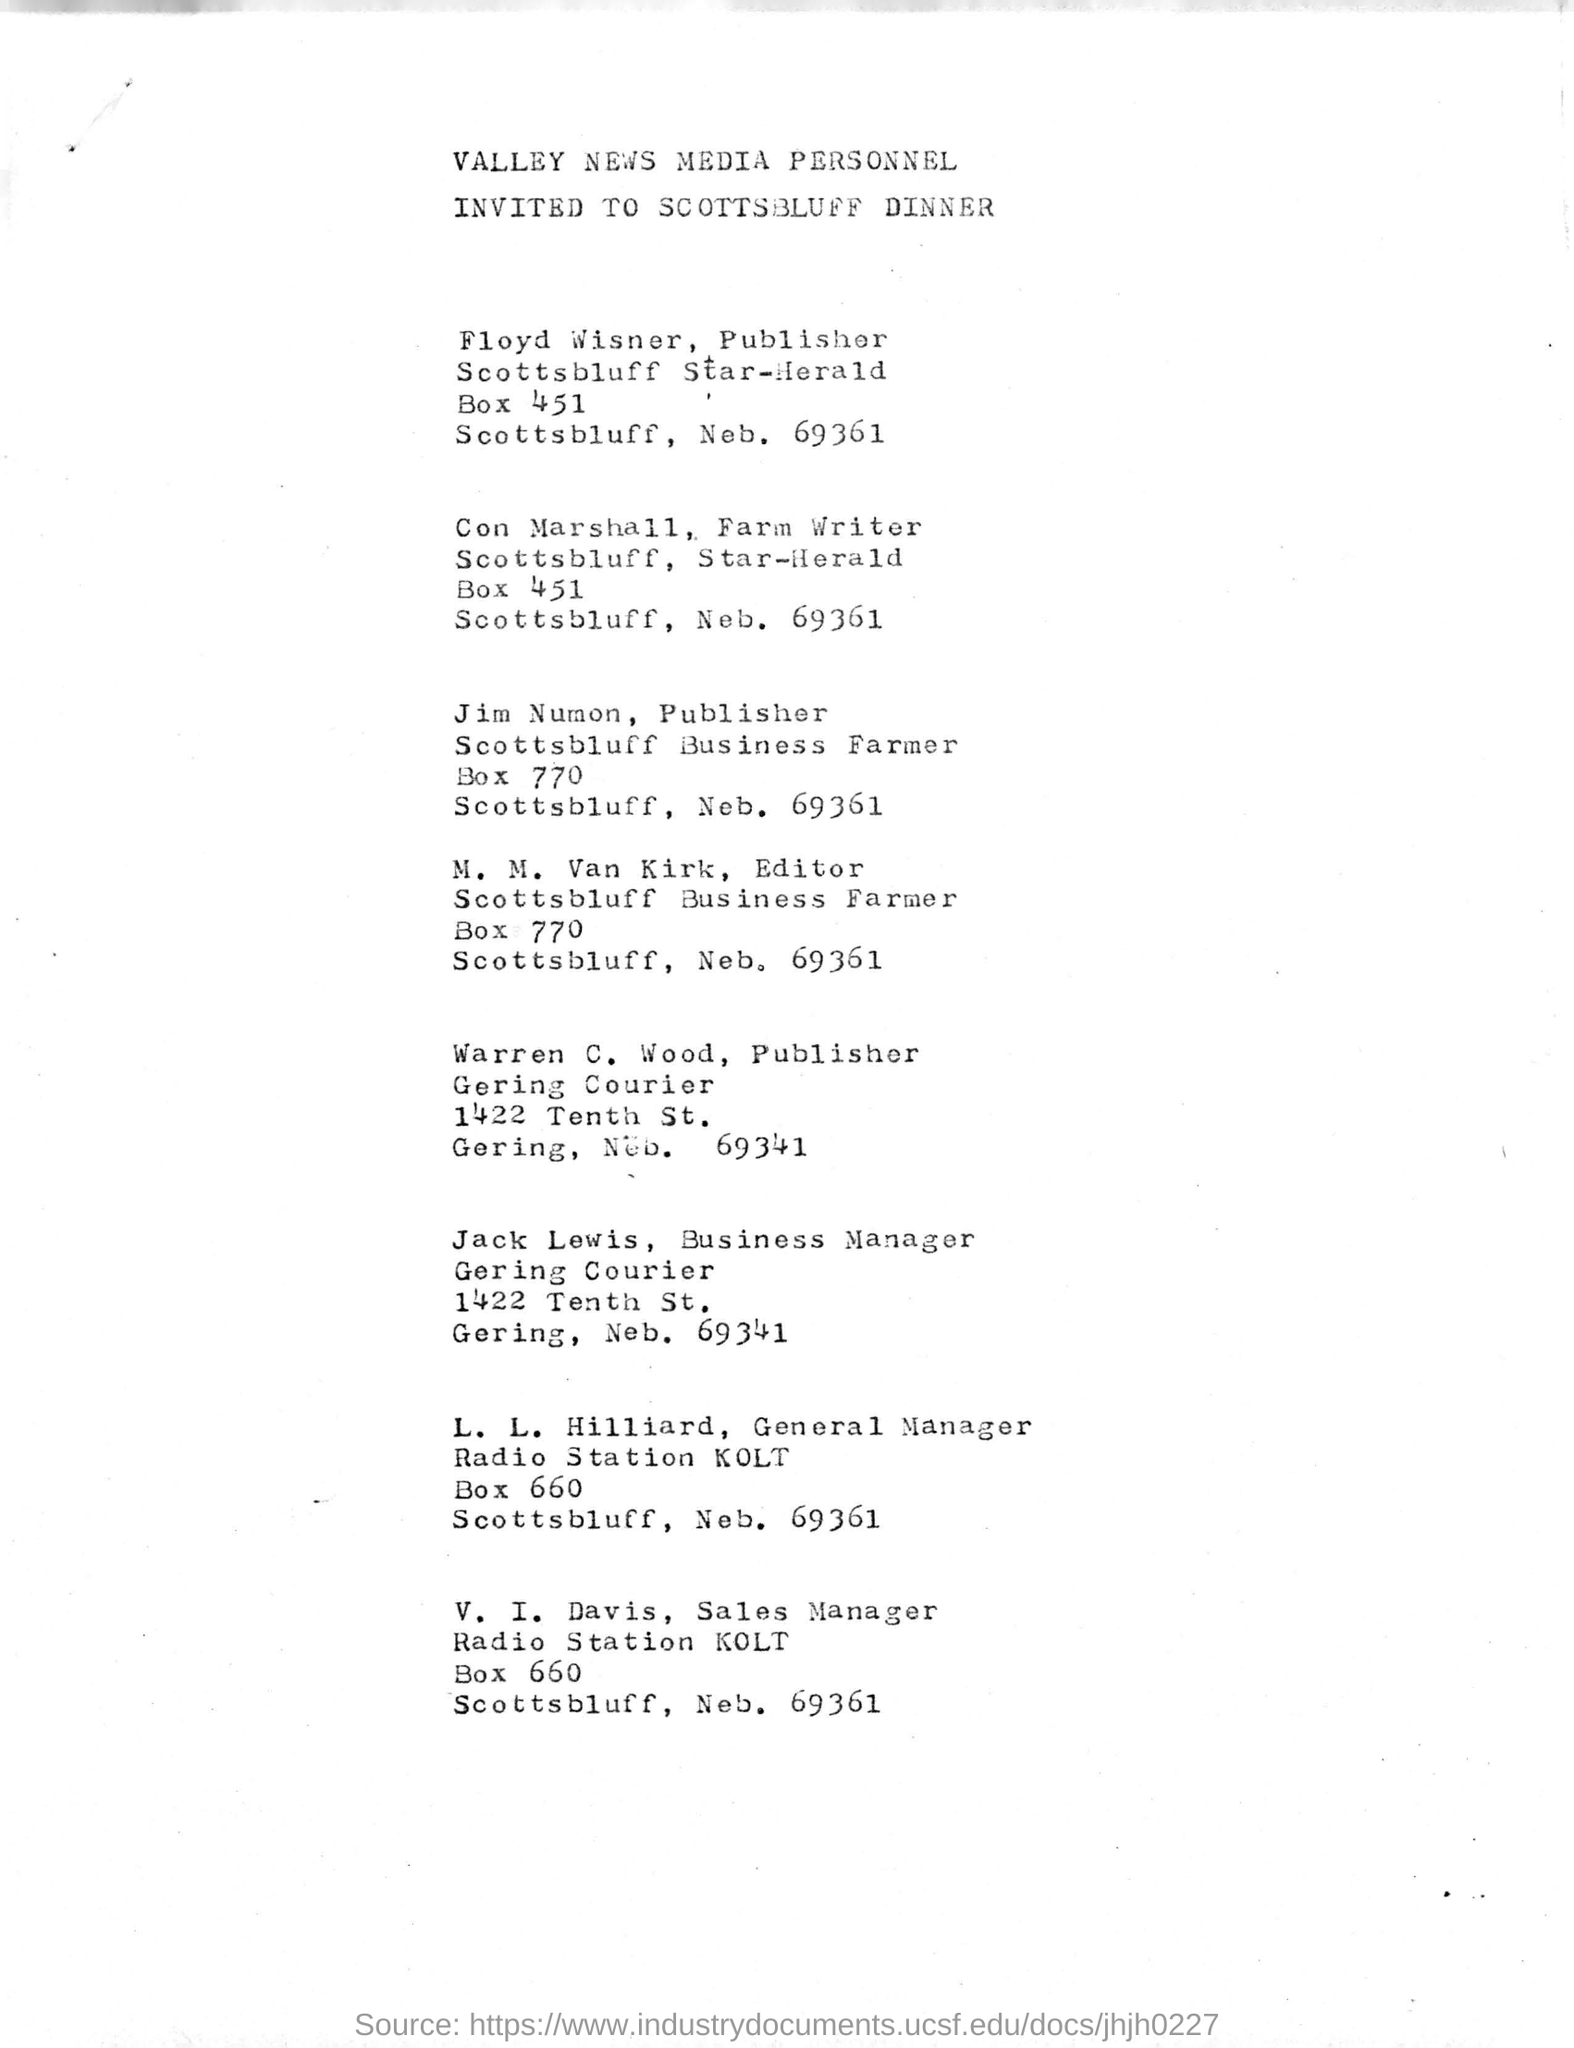Where is VALLEY NEWS MEDIA PERSONNEL invited to?
Keep it short and to the point. SCOTTSBLUFF DINNER. What is the last name on this document?
Keep it short and to the point. V. I. DAVIS. What is the address of Floyd Wisner?
Keep it short and to the point. Scottsbluff Star-Herald Box 451. What is the second last name in this document?
Your answer should be compact. L. L. Hilliard. 